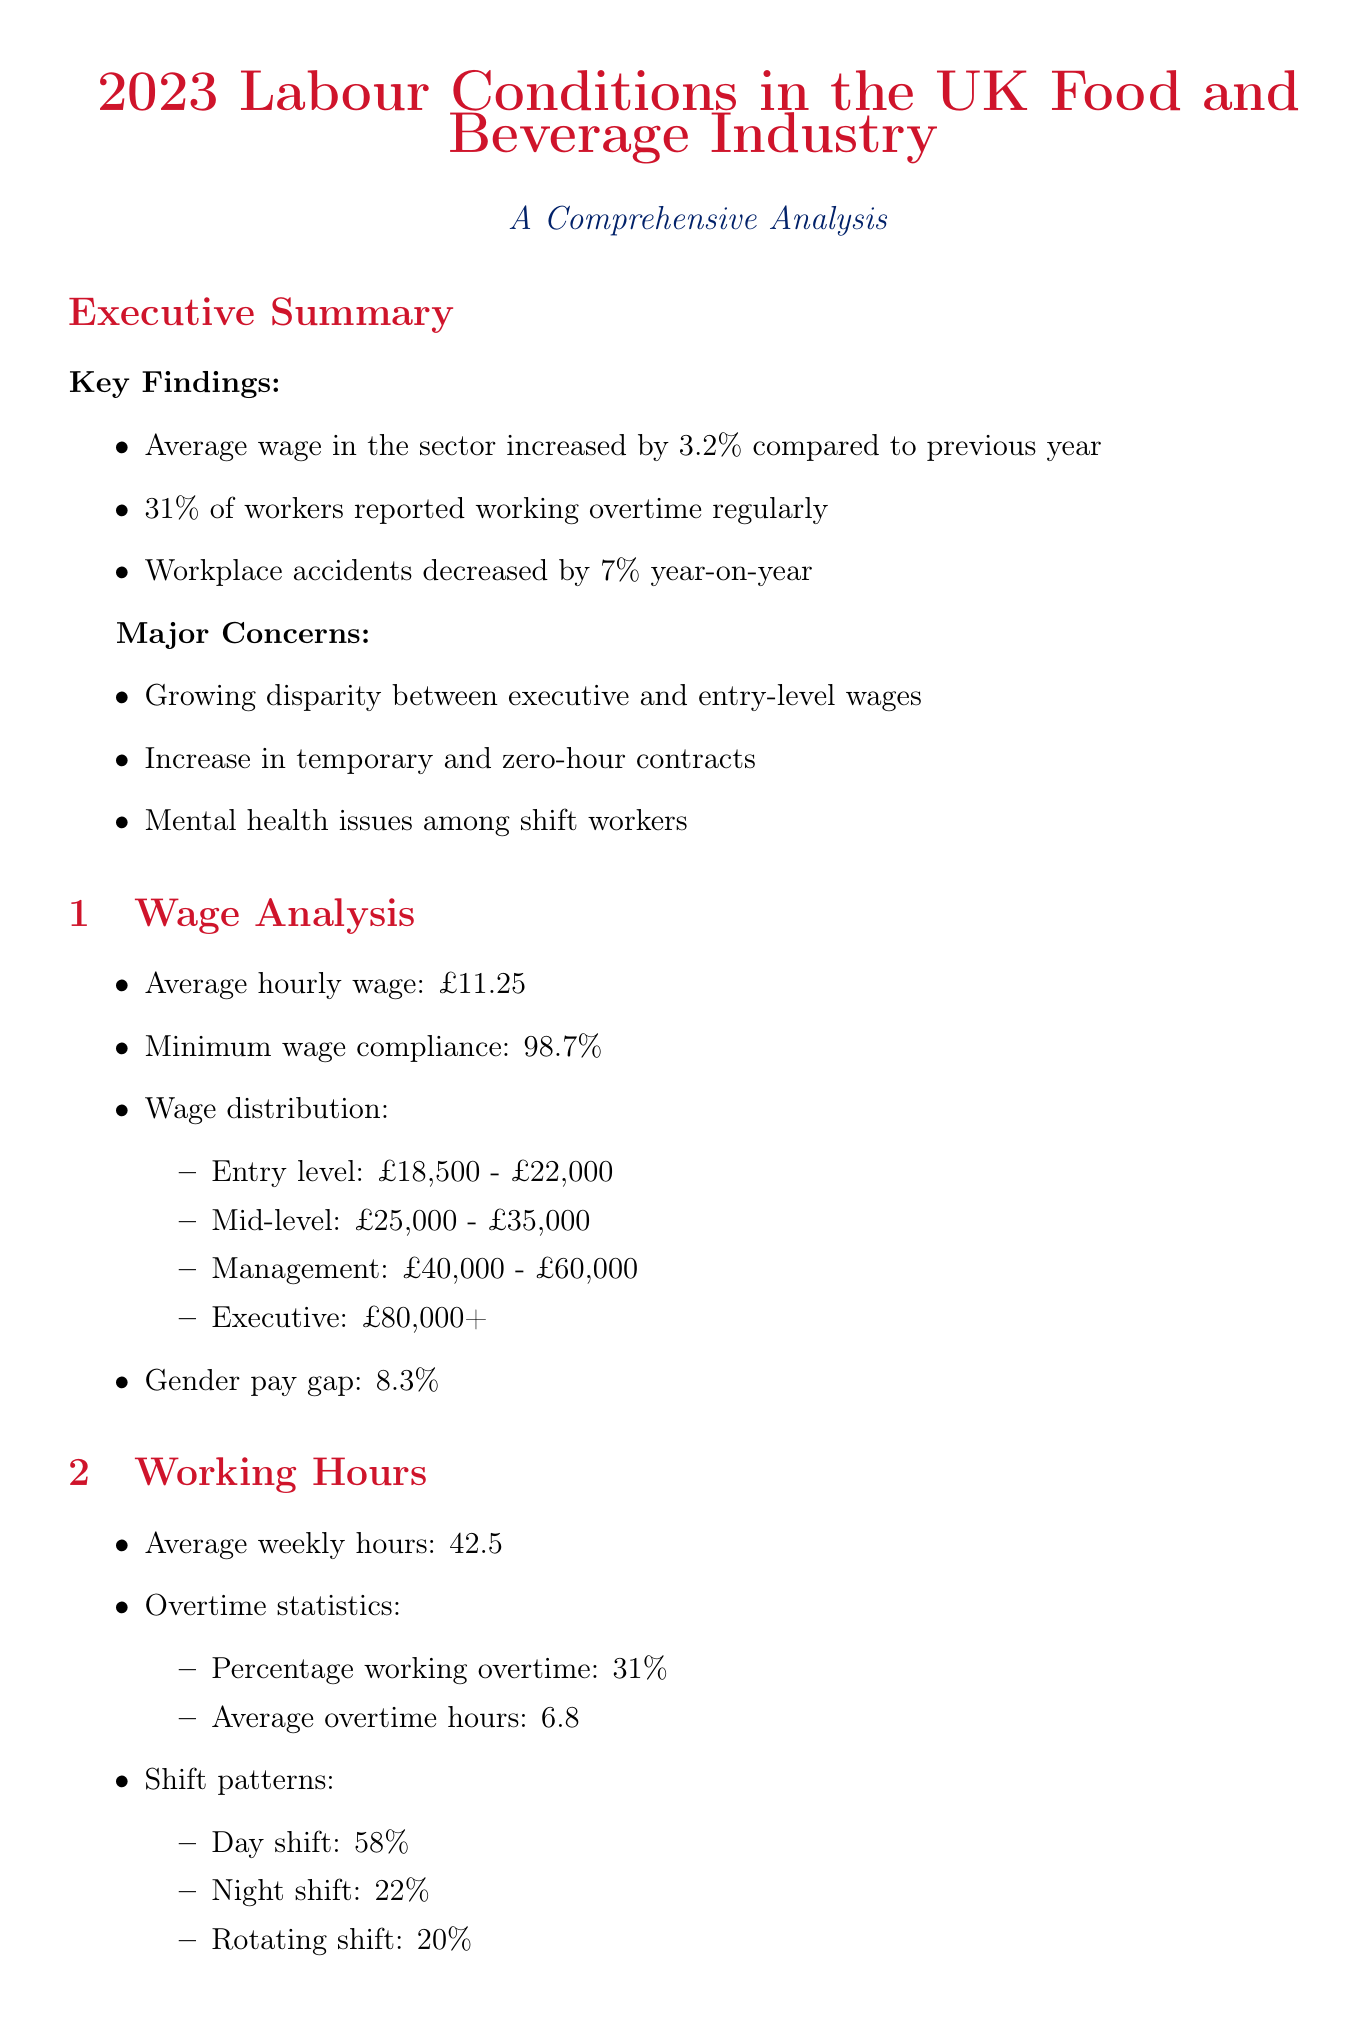What is the average hourly wage in the sector? The average hourly wage is stated in the wage analysis section of the report.
Answer: £11.25 What percentage of workers reported working overtime regularly? This information is found in the working hours section of the document.
Answer: 31% What is the gender pay gap reported in the document? The gender pay gap is provided in the wage analysis section of the report.
Answer: 8.3% What was the increase in productivity after the four-day work week trial at Nestlé UK? This data is part of the case studies included in the document.
Answer: 8% What proportion of the workforce is unionized? The percentage of union membership is mentioned in the industry trends section.
Answer: 23% What safety training compliance rate is reported? The compliance rate for safety training can be found in the workplace safety section.
Answer: 94% What is the reported decrease in workplace accidents year-on-year? This statistic is included in the executive summary.
Answer: 7% What key initiative did Sainsbury's implement to reduce staff turnover? This information is part of the case studies provided in the report.
Answer: Living Wage commitment What percentage of jobs is at risk due to automation? This statistic is included in the industry trends section of the document.
Answer: 15% 